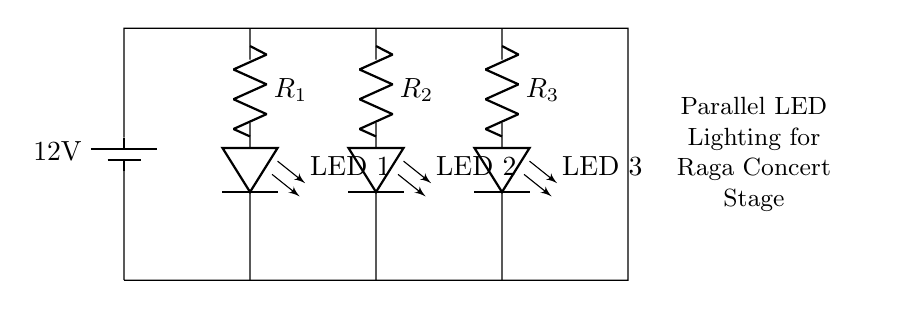What is the voltage of this circuit? The voltage of the circuit is 12 volts, as indicated by the battery symbol which shows the power source voltage.
Answer: 12 volts How many LEDs are connected in parallel? There are three LEDs in parallel, as seen in the diagram where each LED is connected separately to the same voltage source.
Answer: Three What are the resistors used for in this circuit? The resistors limit the current flowing through each LED to prevent them from burning out, ensuring they receive the appropriate amount of current for operation.
Answer: Current limitation What does the parallel configuration imply about the voltage across the LEDs? In a parallel configuration, all components connected share the same voltage across them, thus each LED experiences the full voltage of the battery (12 volts).
Answer: Same voltage What would happen if one LED fails in this circuit? If one LED fails, the other LEDs will continue to operate normally because they are connected in parallel and are independently powered by the same voltage source.
Answer: Other LEDs remain on What is the main purpose of this circuit layout for a concert stage? The main purpose is to provide illumination for the concert stage, enhancing visibility during performances while allowing for design flexibility and even light distribution.
Answer: Stage illumination 